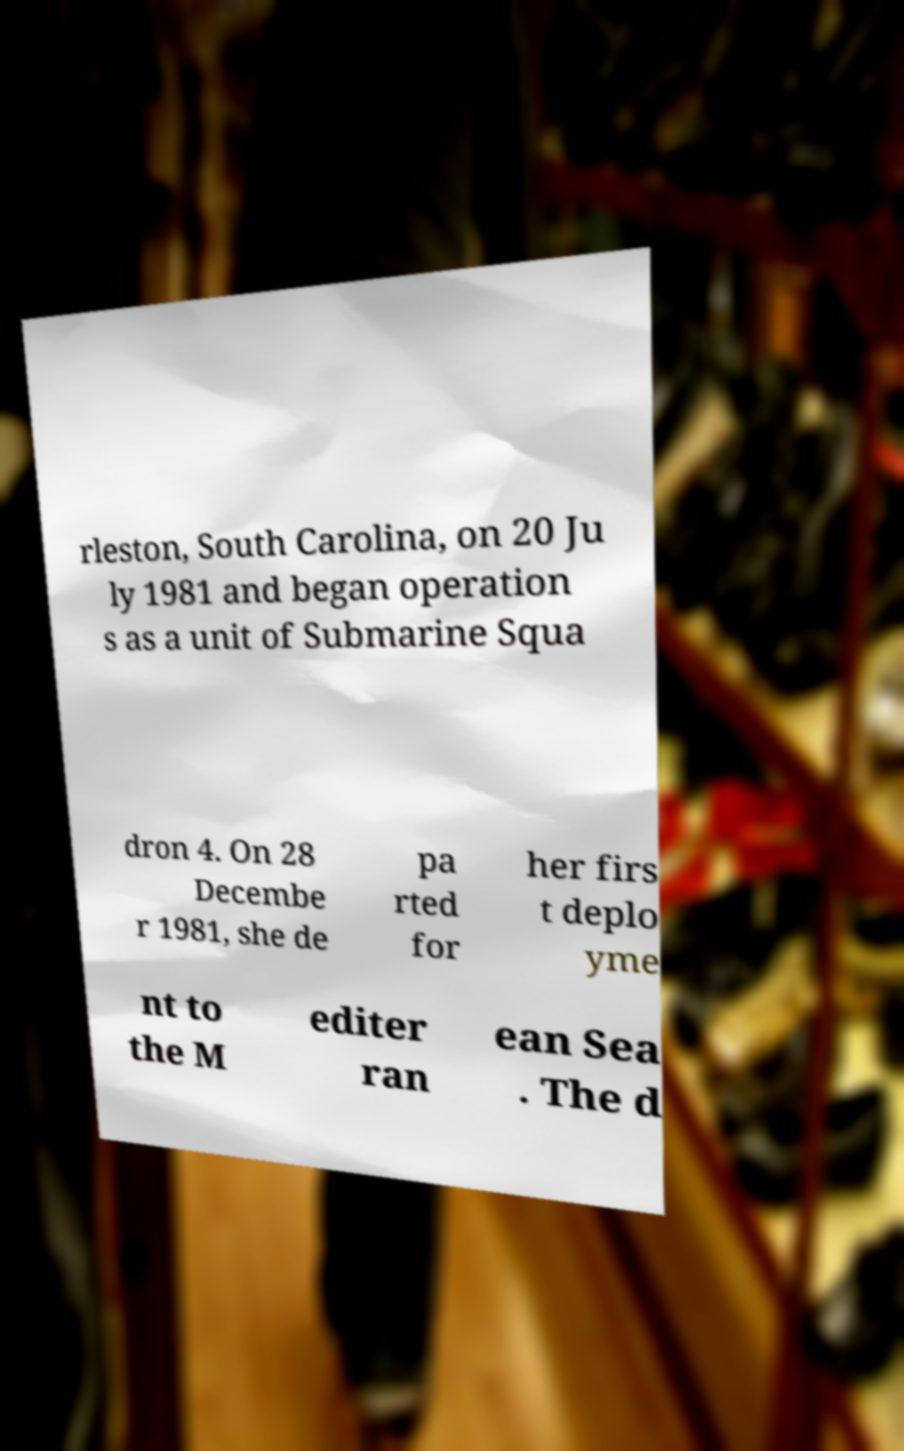Could you extract and type out the text from this image? rleston, South Carolina, on 20 Ju ly 1981 and began operation s as a unit of Submarine Squa dron 4. On 28 Decembe r 1981, she de pa rted for her firs t deplo yme nt to the M editer ran ean Sea . The d 